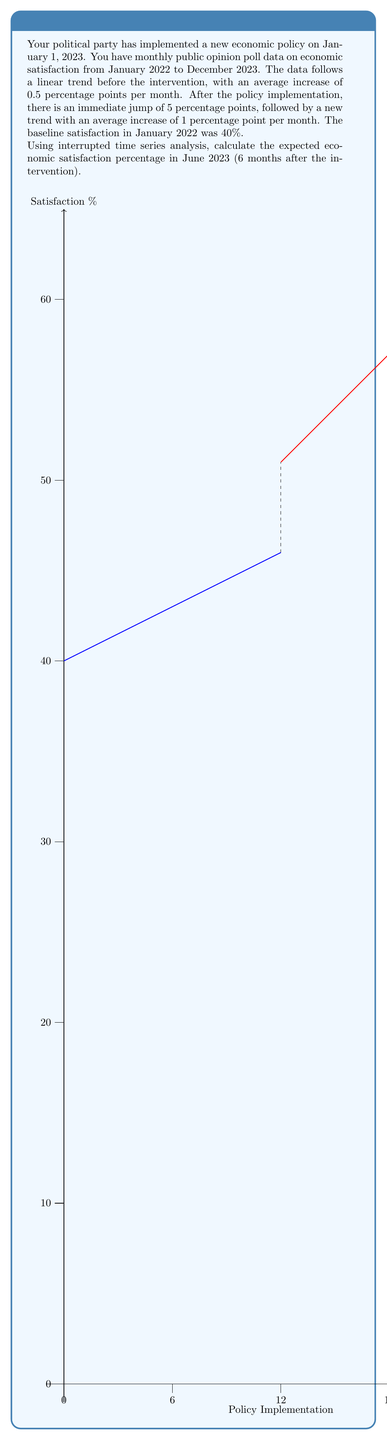Can you solve this math problem? To solve this problem using interrupted time series analysis, we'll follow these steps:

1) Identify the components of the model:
   - Baseline level: $\beta_0 = 40\%$
   - Pre-intervention slope: $\beta_1 = 0.5$ percentage points/month
   - Level change after intervention: $\beta_2 = 5$ percentage points
   - Slope change after intervention: $\beta_3 = 0.5$ percentage points/month
     (1 - 0.5 = 0.5, the difference between post and pre-intervention slopes)

2) The general equation for interrupted time series is:
   $$Y_t = \beta_0 + \beta_1 \cdot t + \beta_2 \cdot X_t + \beta_3 \cdot (t - t_0) \cdot X_t$$
   Where:
   - $Y_t$ is the outcome at time t
   - $t$ is the time since start of observation
   - $X_t$ is a dummy variable (0 before intervention, 1 after)
   - $t_0$ is the time of intervention

3) In our case, June 2023 is 18 months from the start (January 2022) and 6 months after the intervention. So:
   $t = 18$, $X_t = 1$, and $(t - t_0) = 6$

4) Plugging into our equation:
   $$Y_{18} = 40 + 0.5 \cdot 18 + 5 \cdot 1 + 0.5 \cdot 6 \cdot 1$$

5) Calculating:
   $$Y_{18} = 40 + 9 + 5 + 3 = 57$$

Therefore, the expected economic satisfaction in June 2023 is 57%.
Answer: 57% 